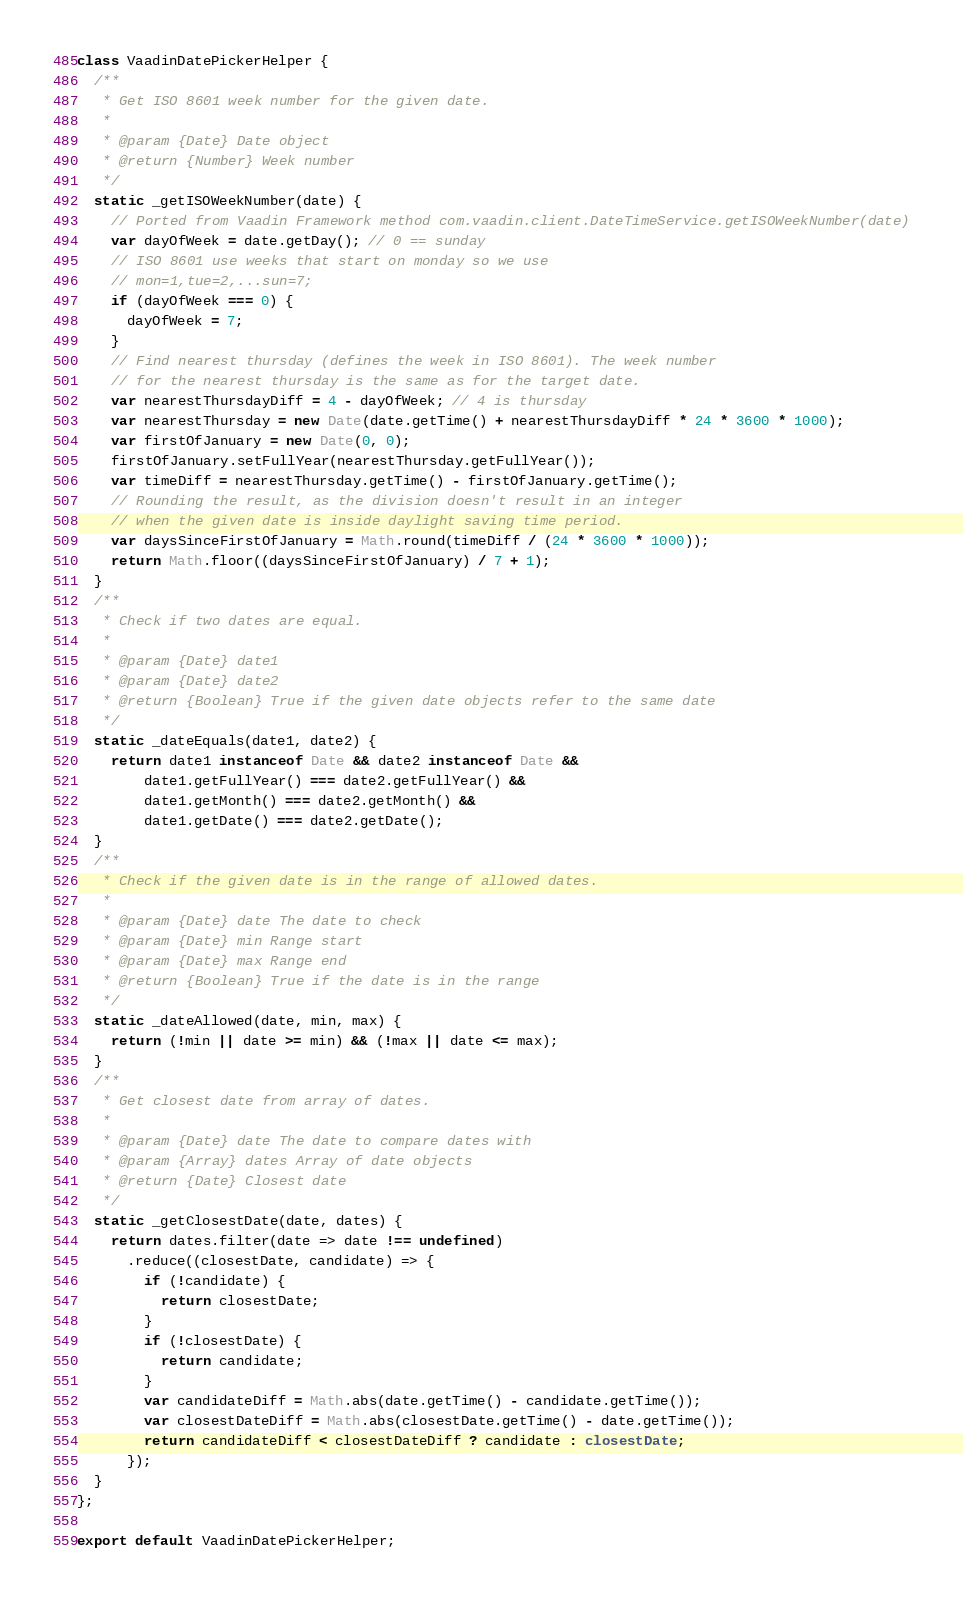Convert code to text. <code><loc_0><loc_0><loc_500><loc_500><_TypeScript_>class VaadinDatePickerHelper {
  /**
   * Get ISO 8601 week number for the given date.
   *
   * @param {Date} Date object
   * @return {Number} Week number
   */
  static _getISOWeekNumber(date) {
    // Ported from Vaadin Framework method com.vaadin.client.DateTimeService.getISOWeekNumber(date)
    var dayOfWeek = date.getDay(); // 0 == sunday
    // ISO 8601 use weeks that start on monday so we use
    // mon=1,tue=2,...sun=7;
    if (dayOfWeek === 0) {
      dayOfWeek = 7;
    }
    // Find nearest thursday (defines the week in ISO 8601). The week number
    // for the nearest thursday is the same as for the target date.
    var nearestThursdayDiff = 4 - dayOfWeek; // 4 is thursday
    var nearestThursday = new Date(date.getTime() + nearestThursdayDiff * 24 * 3600 * 1000);
    var firstOfJanuary = new Date(0, 0);
    firstOfJanuary.setFullYear(nearestThursday.getFullYear());
    var timeDiff = nearestThursday.getTime() - firstOfJanuary.getTime();
    // Rounding the result, as the division doesn't result in an integer
    // when the given date is inside daylight saving time period.
    var daysSinceFirstOfJanuary = Math.round(timeDiff / (24 * 3600 * 1000));
    return Math.floor((daysSinceFirstOfJanuary) / 7 + 1);
  }
  /**
   * Check if two dates are equal.
   *
   * @param {Date} date1
   * @param {Date} date2
   * @return {Boolean} True if the given date objects refer to the same date
   */
  static _dateEquals(date1, date2) {
    return date1 instanceof Date && date2 instanceof Date &&
        date1.getFullYear() === date2.getFullYear() &&
        date1.getMonth() === date2.getMonth() &&
        date1.getDate() === date2.getDate();
  }
  /**
   * Check if the given date is in the range of allowed dates.
   *
   * @param {Date} date The date to check
   * @param {Date} min Range start
   * @param {Date} max Range end
   * @return {Boolean} True if the date is in the range
   */
  static _dateAllowed(date, min, max) {
    return (!min || date >= min) && (!max || date <= max);
  }
  /**
   * Get closest date from array of dates.
   *
   * @param {Date} date The date to compare dates with
   * @param {Array} dates Array of date objects
   * @return {Date} Closest date
   */
  static _getClosestDate(date, dates) {
    return dates.filter(date => date !== undefined)
      .reduce((closestDate, candidate) => {
        if (!candidate) {
          return closestDate;
        }
        if (!closestDate) {
          return candidate;
        }
        var candidateDiff = Math.abs(date.getTime() - candidate.getTime());
        var closestDateDiff = Math.abs(closestDate.getTime() - date.getTime());
        return candidateDiff < closestDateDiff ? candidate : closestDate;
      });
  }
};

export default VaadinDatePickerHelper;
</code> 